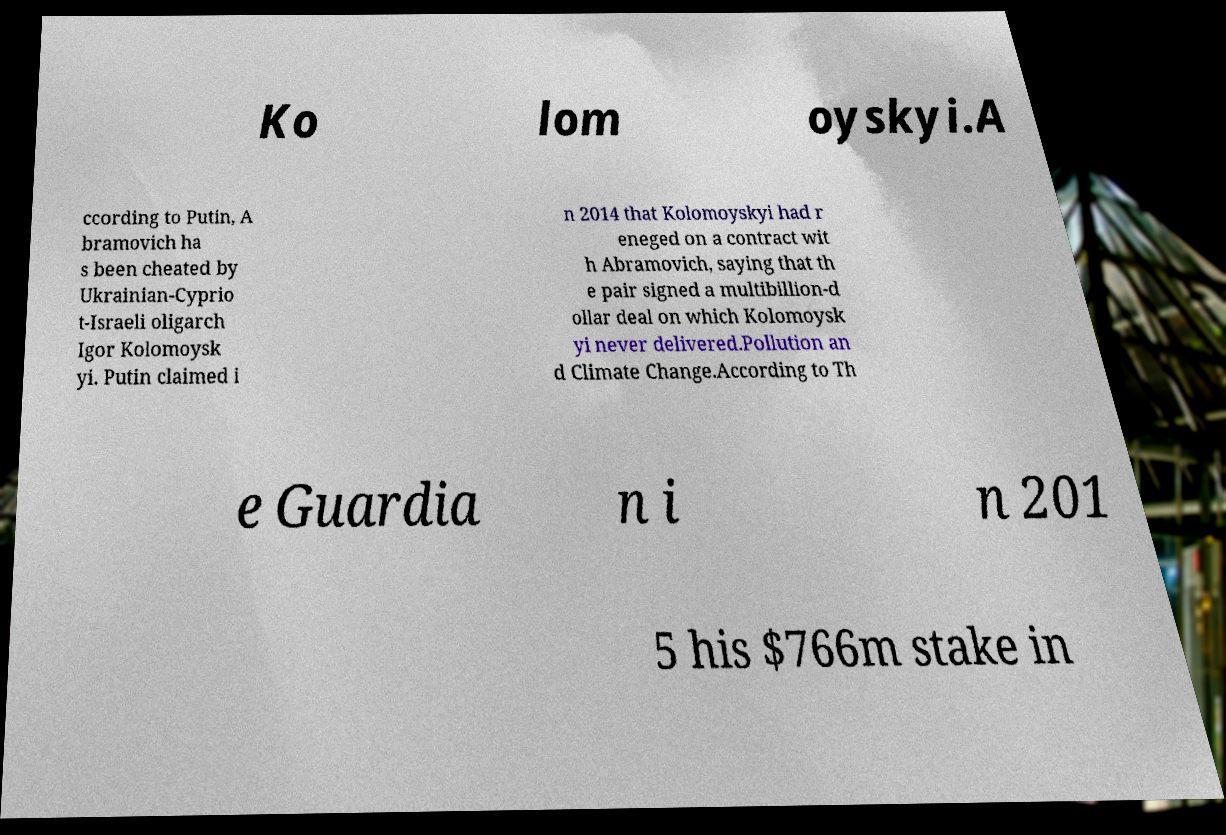Please read and relay the text visible in this image. What does it say? Ko lom oyskyi.A ccording to Putin, A bramovich ha s been cheated by Ukrainian-Cyprio t-Israeli oligarch Igor Kolomoysk yi. Putin claimed i n 2014 that Kolomoyskyi had r eneged on a contract wit h Abramovich, saying that th e pair signed a multibillion-d ollar deal on which Kolomoysk yi never delivered.Pollution an d Climate Change.According to Th e Guardia n i n 201 5 his $766m stake in 